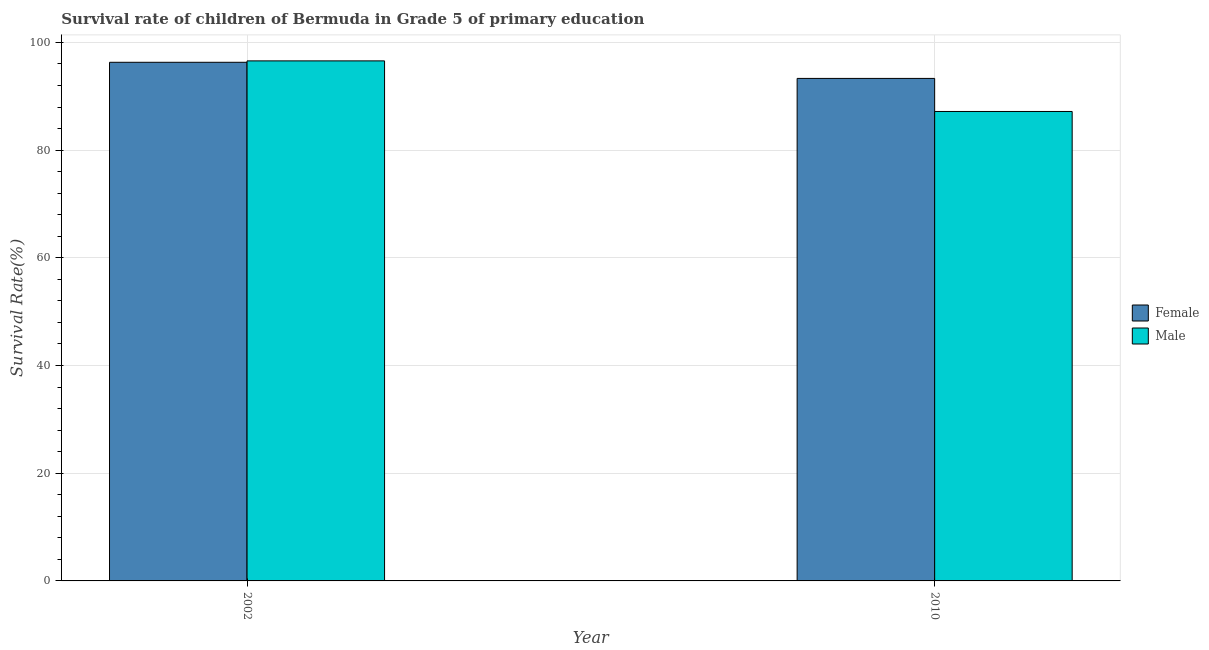How many different coloured bars are there?
Keep it short and to the point. 2. Are the number of bars per tick equal to the number of legend labels?
Give a very brief answer. Yes. Are the number of bars on each tick of the X-axis equal?
Offer a terse response. Yes. What is the label of the 2nd group of bars from the left?
Your answer should be compact. 2010. In how many cases, is the number of bars for a given year not equal to the number of legend labels?
Ensure brevity in your answer.  0. What is the survival rate of female students in primary education in 2002?
Make the answer very short. 96.31. Across all years, what is the maximum survival rate of male students in primary education?
Your answer should be very brief. 96.57. Across all years, what is the minimum survival rate of male students in primary education?
Offer a very short reply. 87.17. What is the total survival rate of female students in primary education in the graph?
Your response must be concise. 189.62. What is the difference between the survival rate of male students in primary education in 2002 and that in 2010?
Offer a very short reply. 9.4. What is the difference between the survival rate of male students in primary education in 2010 and the survival rate of female students in primary education in 2002?
Offer a very short reply. -9.4. What is the average survival rate of female students in primary education per year?
Ensure brevity in your answer.  94.81. In the year 2002, what is the difference between the survival rate of female students in primary education and survival rate of male students in primary education?
Keep it short and to the point. 0. In how many years, is the survival rate of male students in primary education greater than 52 %?
Your answer should be very brief. 2. What is the ratio of the survival rate of male students in primary education in 2002 to that in 2010?
Offer a very short reply. 1.11. What does the 2nd bar from the right in 2002 represents?
Offer a very short reply. Female. How many bars are there?
Your answer should be compact. 4. Are all the bars in the graph horizontal?
Ensure brevity in your answer.  No. How many years are there in the graph?
Your answer should be compact. 2. What is the difference between two consecutive major ticks on the Y-axis?
Make the answer very short. 20. Does the graph contain any zero values?
Your answer should be very brief. No. Does the graph contain grids?
Ensure brevity in your answer.  Yes. How many legend labels are there?
Your answer should be very brief. 2. What is the title of the graph?
Offer a terse response. Survival rate of children of Bermuda in Grade 5 of primary education. Does "Excluding technical cooperation" appear as one of the legend labels in the graph?
Offer a very short reply. No. What is the label or title of the X-axis?
Your answer should be very brief. Year. What is the label or title of the Y-axis?
Your response must be concise. Survival Rate(%). What is the Survival Rate(%) in Female in 2002?
Your answer should be very brief. 96.31. What is the Survival Rate(%) in Male in 2002?
Provide a short and direct response. 96.57. What is the Survival Rate(%) of Female in 2010?
Your response must be concise. 93.31. What is the Survival Rate(%) in Male in 2010?
Keep it short and to the point. 87.17. Across all years, what is the maximum Survival Rate(%) of Female?
Provide a short and direct response. 96.31. Across all years, what is the maximum Survival Rate(%) in Male?
Offer a terse response. 96.57. Across all years, what is the minimum Survival Rate(%) of Female?
Your answer should be very brief. 93.31. Across all years, what is the minimum Survival Rate(%) of Male?
Give a very brief answer. 87.17. What is the total Survival Rate(%) in Female in the graph?
Ensure brevity in your answer.  189.62. What is the total Survival Rate(%) of Male in the graph?
Provide a short and direct response. 183.74. What is the difference between the Survival Rate(%) in Female in 2002 and that in 2010?
Your response must be concise. 3. What is the difference between the Survival Rate(%) of Male in 2002 and that in 2010?
Offer a terse response. 9.4. What is the difference between the Survival Rate(%) of Female in 2002 and the Survival Rate(%) of Male in 2010?
Your answer should be compact. 9.13. What is the average Survival Rate(%) of Female per year?
Keep it short and to the point. 94.81. What is the average Survival Rate(%) of Male per year?
Make the answer very short. 91.87. In the year 2002, what is the difference between the Survival Rate(%) of Female and Survival Rate(%) of Male?
Offer a very short reply. -0.26. In the year 2010, what is the difference between the Survival Rate(%) in Female and Survival Rate(%) in Male?
Provide a short and direct response. 6.14. What is the ratio of the Survival Rate(%) of Female in 2002 to that in 2010?
Make the answer very short. 1.03. What is the ratio of the Survival Rate(%) in Male in 2002 to that in 2010?
Offer a terse response. 1.11. What is the difference between the highest and the second highest Survival Rate(%) in Female?
Keep it short and to the point. 3. What is the difference between the highest and the second highest Survival Rate(%) in Male?
Offer a very short reply. 9.4. What is the difference between the highest and the lowest Survival Rate(%) in Female?
Provide a succinct answer. 3. What is the difference between the highest and the lowest Survival Rate(%) of Male?
Keep it short and to the point. 9.4. 